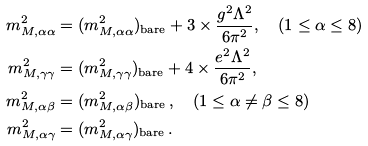Convert formula to latex. <formula><loc_0><loc_0><loc_500><loc_500>m _ { M , \alpha \alpha } ^ { 2 } & = ( m _ { M , \alpha \alpha } ^ { 2 } ) _ { \text {bare} } + 3 \times \frac { g ^ { 2 } \Lambda ^ { 2 } } { 6 \pi ^ { 2 } } , \quad ( 1 \leq \alpha \leq 8 ) \\ m _ { M , \gamma \gamma } ^ { 2 } & = ( m _ { M , \gamma \gamma } ^ { 2 } ) _ { \text {bare} } + 4 \times \frac { e ^ { 2 } \Lambda ^ { 2 } } { 6 \pi ^ { 2 } } , \\ m _ { M , \alpha \beta } ^ { 2 } & = ( m _ { M , \alpha \beta } ^ { 2 } ) _ { \text {bare} } \, , \quad ( 1 \leq \alpha \neq \beta \leq 8 ) \\ m _ { M , \alpha \gamma } ^ { 2 } & = ( m _ { M , \alpha \gamma } ^ { 2 } ) _ { \text {bare} } \, .</formula> 